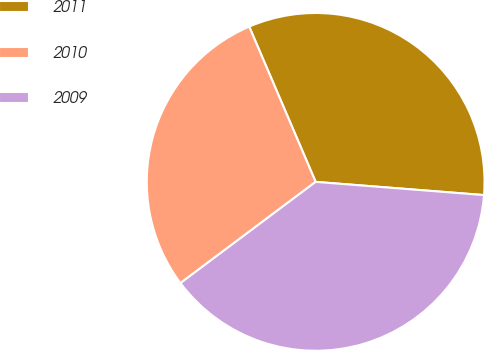Convert chart. <chart><loc_0><loc_0><loc_500><loc_500><pie_chart><fcel>2011<fcel>2010<fcel>2009<nl><fcel>32.68%<fcel>28.79%<fcel>38.52%<nl></chart> 